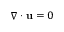<formula> <loc_0><loc_0><loc_500><loc_500>\nabla \cdot { u } = 0</formula> 